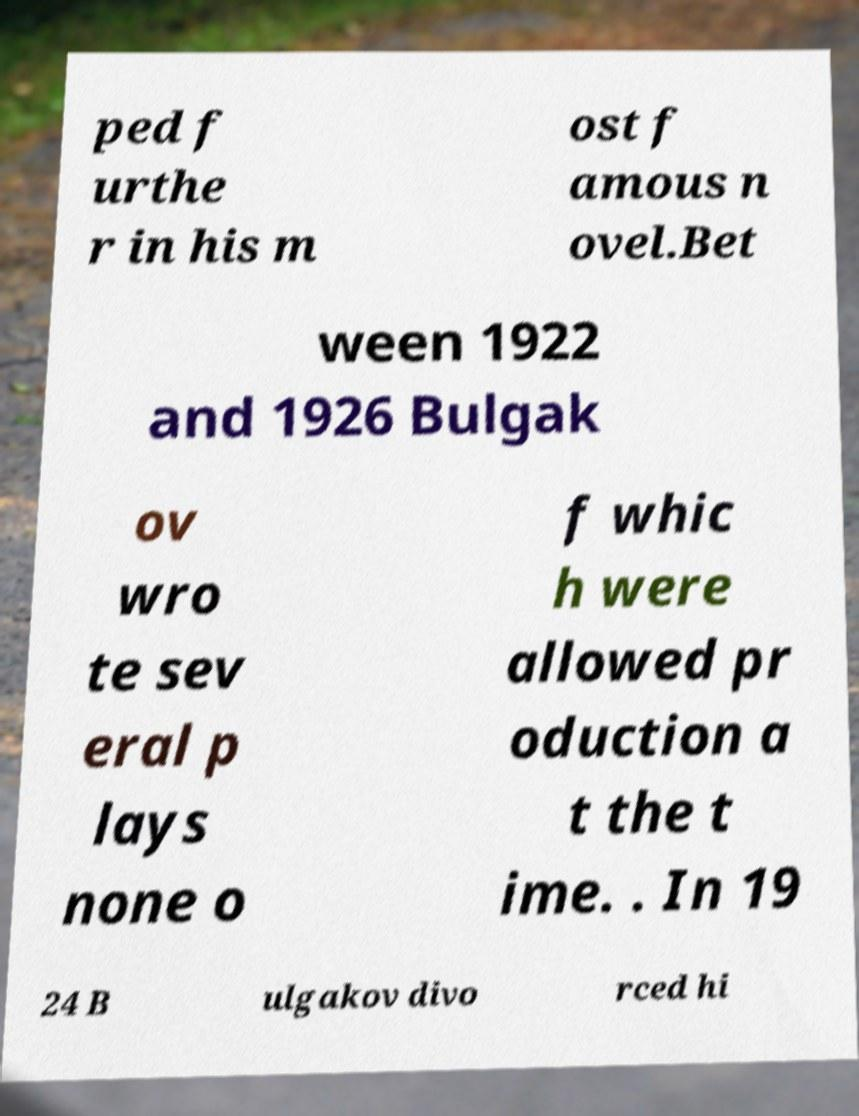Could you assist in decoding the text presented in this image and type it out clearly? ped f urthe r in his m ost f amous n ovel.Bet ween 1922 and 1926 Bulgak ov wro te sev eral p lays none o f whic h were allowed pr oduction a t the t ime. . In 19 24 B ulgakov divo rced hi 